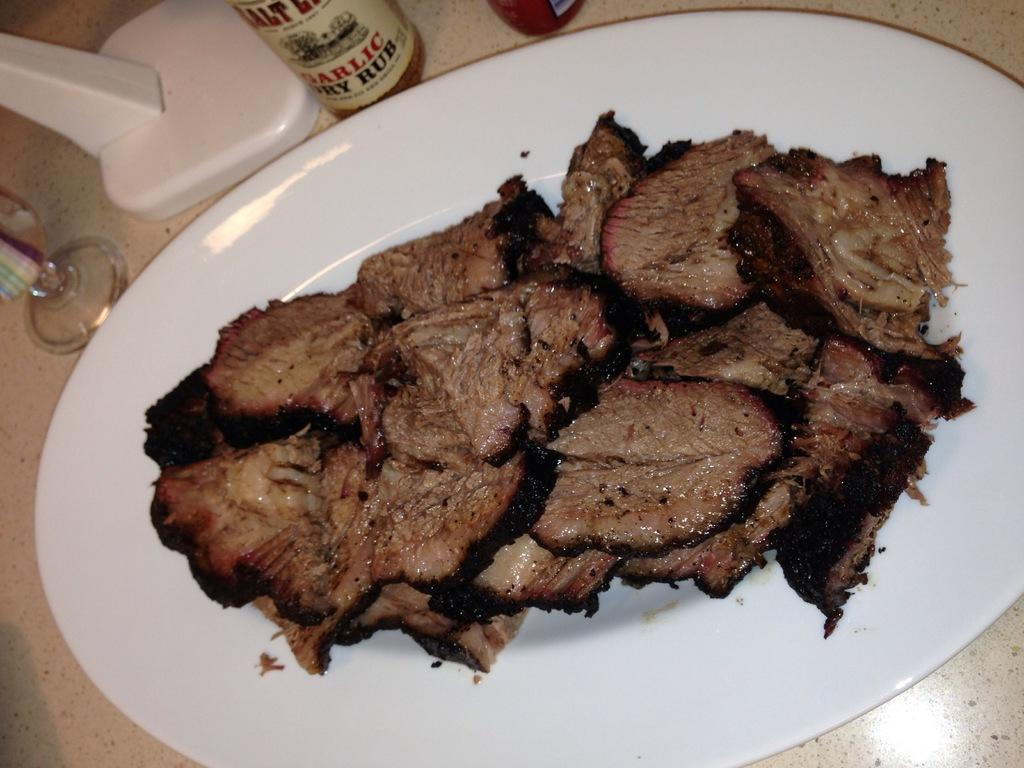<image>
Relay a brief, clear account of the picture shown. A bottle of garlic dry rub sits next to a plate of cooked meat. 